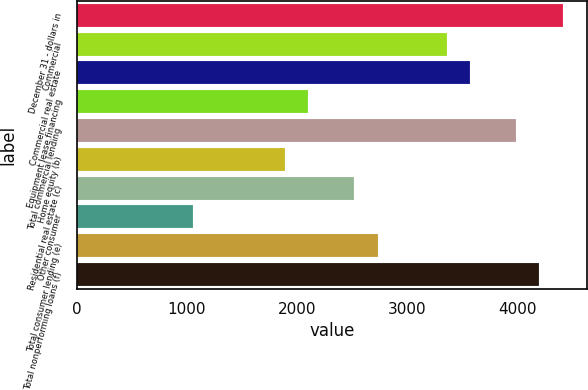Convert chart to OTSL. <chart><loc_0><loc_0><loc_500><loc_500><bar_chart><fcel>December 31 - dollars in<fcel>Commercial<fcel>Commercial real estate<fcel>Equipment lease financing<fcel>Total commercial lending<fcel>Home equity (b)<fcel>Residential real estate (c)<fcel>Other consumer<fcel>Total consumer lending (e)<fcel>Total nonperforming loans (f)<nl><fcel>4409.25<fcel>3359.6<fcel>3569.53<fcel>2100.02<fcel>3989.39<fcel>1890.09<fcel>2519.88<fcel>1050.37<fcel>2729.81<fcel>4199.32<nl></chart> 